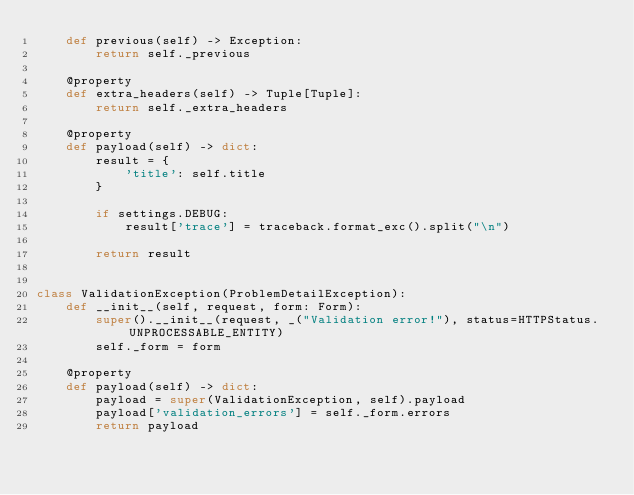<code> <loc_0><loc_0><loc_500><loc_500><_Python_>    def previous(self) -> Exception:
        return self._previous

    @property
    def extra_headers(self) -> Tuple[Tuple]:
        return self._extra_headers

    @property
    def payload(self) -> dict:
        result = {
            'title': self.title
        }

        if settings.DEBUG:
            result['trace'] = traceback.format_exc().split("\n")

        return result


class ValidationException(ProblemDetailException):
    def __init__(self, request, form: Form):
        super().__init__(request, _("Validation error!"), status=HTTPStatus.UNPROCESSABLE_ENTITY)
        self._form = form

    @property
    def payload(self) -> dict:
        payload = super(ValidationException, self).payload
        payload['validation_errors'] = self._form.errors
        return payload
</code> 